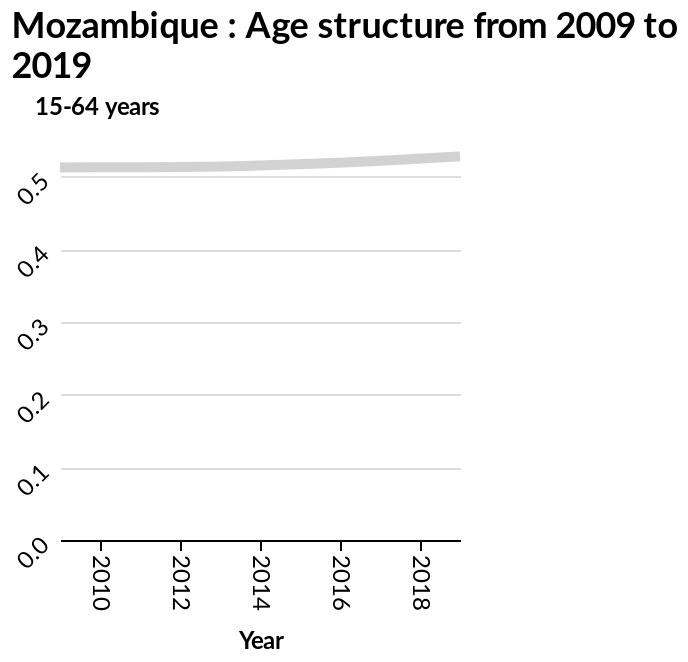<image>
What does the relation between age structure and year show?  The relation between age structure and year increases along the y-axis. please enumerates aspects of the construction of the chart Mozambique : Age structure from 2009 to 2019 is a line chart. The x-axis measures Year while the y-axis plots 15-64 years. What age group is represented on the y-axis in the line chart of Mozambique's age structure from 2009 to 2019? The y-axis in the line chart of Mozambique's age structure from 2009 to 2019 represents the age group of 15-64 years. What does the x-axis represent in the line chart of Mozambique's age structure from 2009 to 2019? In the line chart of Mozambique's age structure from 2009 to 2019, the x-axis represents the years. 